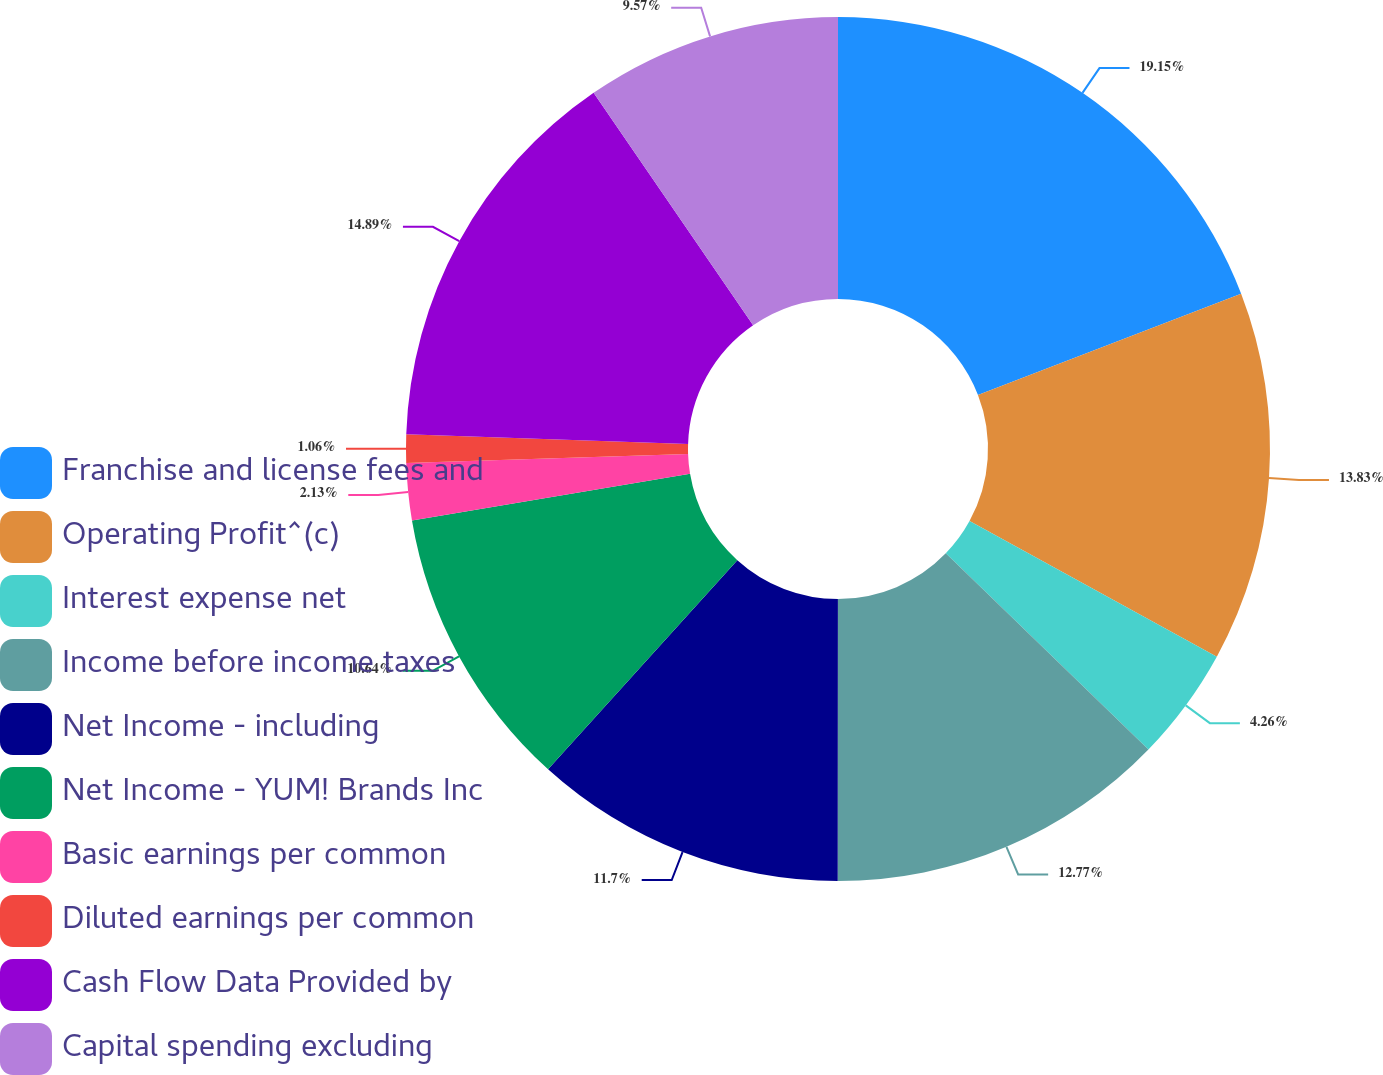Convert chart. <chart><loc_0><loc_0><loc_500><loc_500><pie_chart><fcel>Franchise and license fees and<fcel>Operating Profit^(c)<fcel>Interest expense net<fcel>Income before income taxes<fcel>Net Income - including<fcel>Net Income - YUM! Brands Inc<fcel>Basic earnings per common<fcel>Diluted earnings per common<fcel>Cash Flow Data Provided by<fcel>Capital spending excluding<nl><fcel>19.15%<fcel>13.83%<fcel>4.26%<fcel>12.77%<fcel>11.7%<fcel>10.64%<fcel>2.13%<fcel>1.06%<fcel>14.89%<fcel>9.57%<nl></chart> 